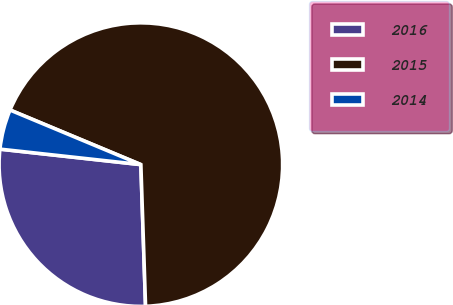Convert chart to OTSL. <chart><loc_0><loc_0><loc_500><loc_500><pie_chart><fcel>2016<fcel>2015<fcel>2014<nl><fcel>27.27%<fcel>68.18%<fcel>4.55%<nl></chart> 